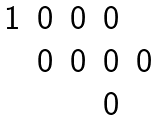Convert formula to latex. <formula><loc_0><loc_0><loc_500><loc_500>\begin{matrix} 1 & 0 & 0 & 0 & \\ & 0 & 0 & 0 & 0 \\ & & & 0 & \\ \end{matrix}</formula> 